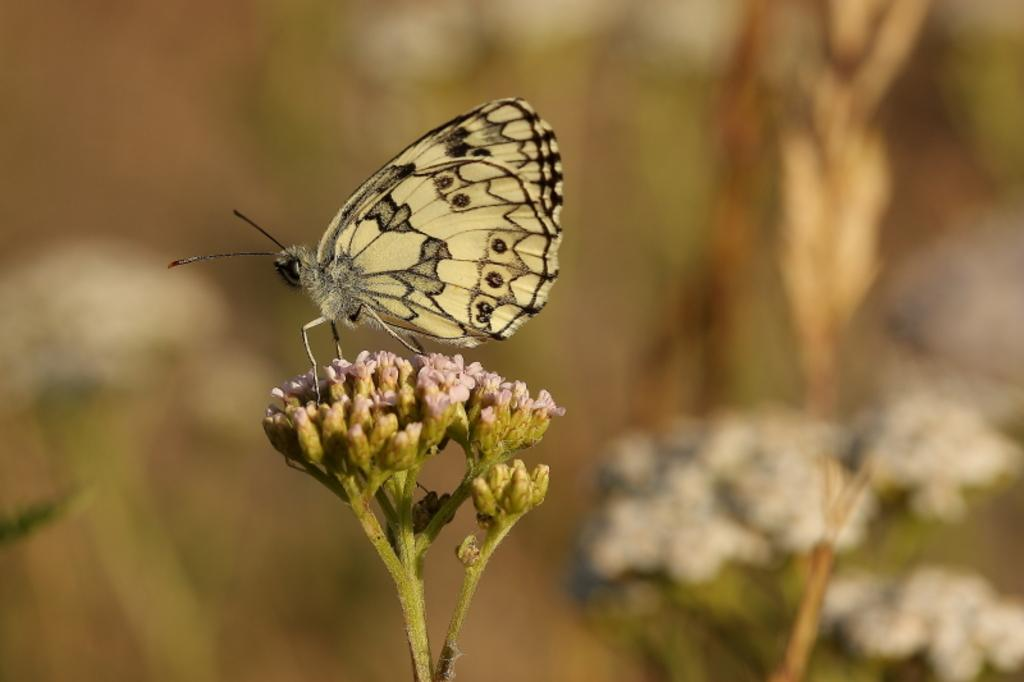What is the main subject of the image? There is a butterfly in the image. Where is the butterfly located? The butterfly is on flowers. Can you describe the background of the image? The background of the image is blurry. What type of cactus can be seen playing in the background of the image? There is no cactus or any indication of playing in the image; it features a butterfly on flowers with a blurry background. 